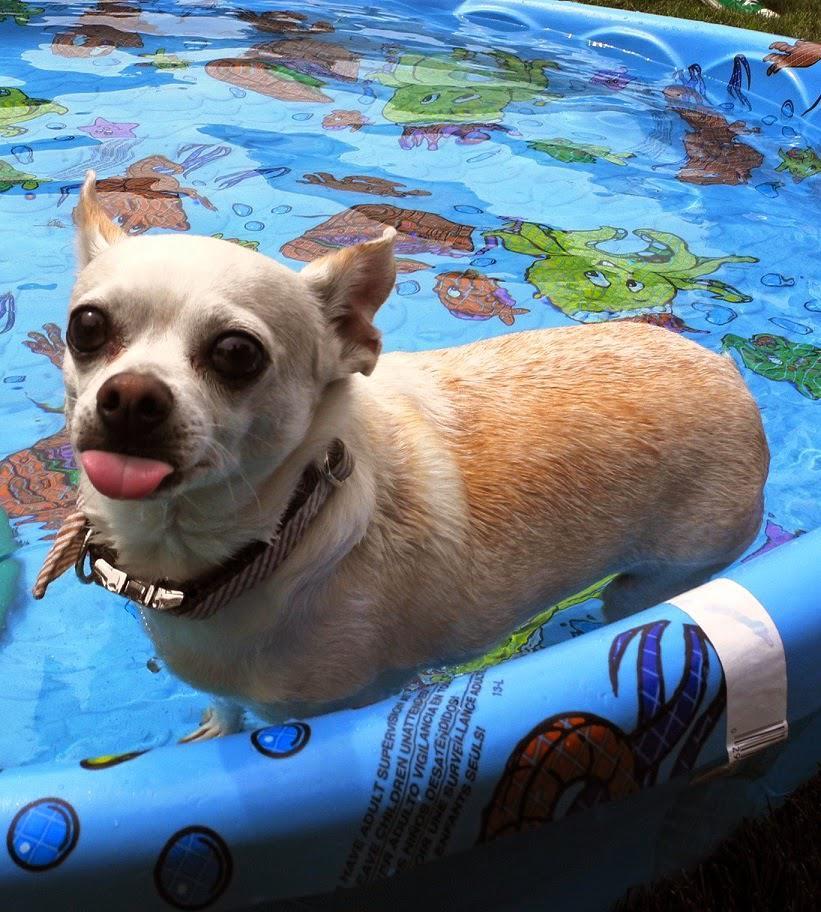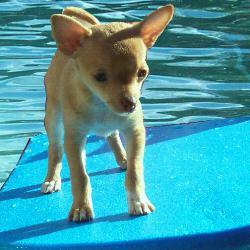The first image is the image on the left, the second image is the image on the right. Examine the images to the left and right. Is the description "An image shows a small dog standing on top of a floating raft-type item." accurate? Answer yes or no. Yes. 